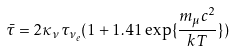<formula> <loc_0><loc_0><loc_500><loc_500>\bar { \tau } = 2 \kappa _ { \nu } \tau _ { \nu _ { e } } ( 1 + 1 . 4 1 \exp \{ \frac { m _ { \mu } c ^ { 2 } } { k T } \} )</formula> 